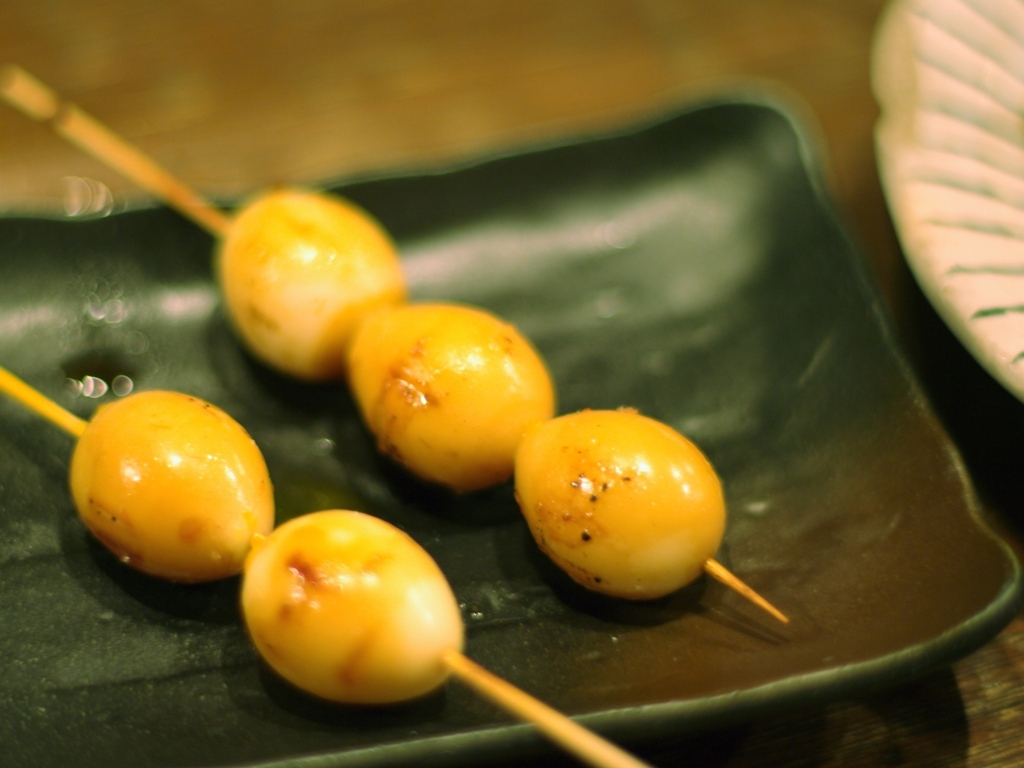How many skewers are visible in the picture and can you describe the plating style? There are three skewers visible in the picture, each containing what appears to be grilled balls. The plating style is minimalistic and modern, with the skewers arranged neatly in a row on a sleek, dark plate that contrasts with the light color of the food. It draws focus to the food while also giving a sense of sophistication. 